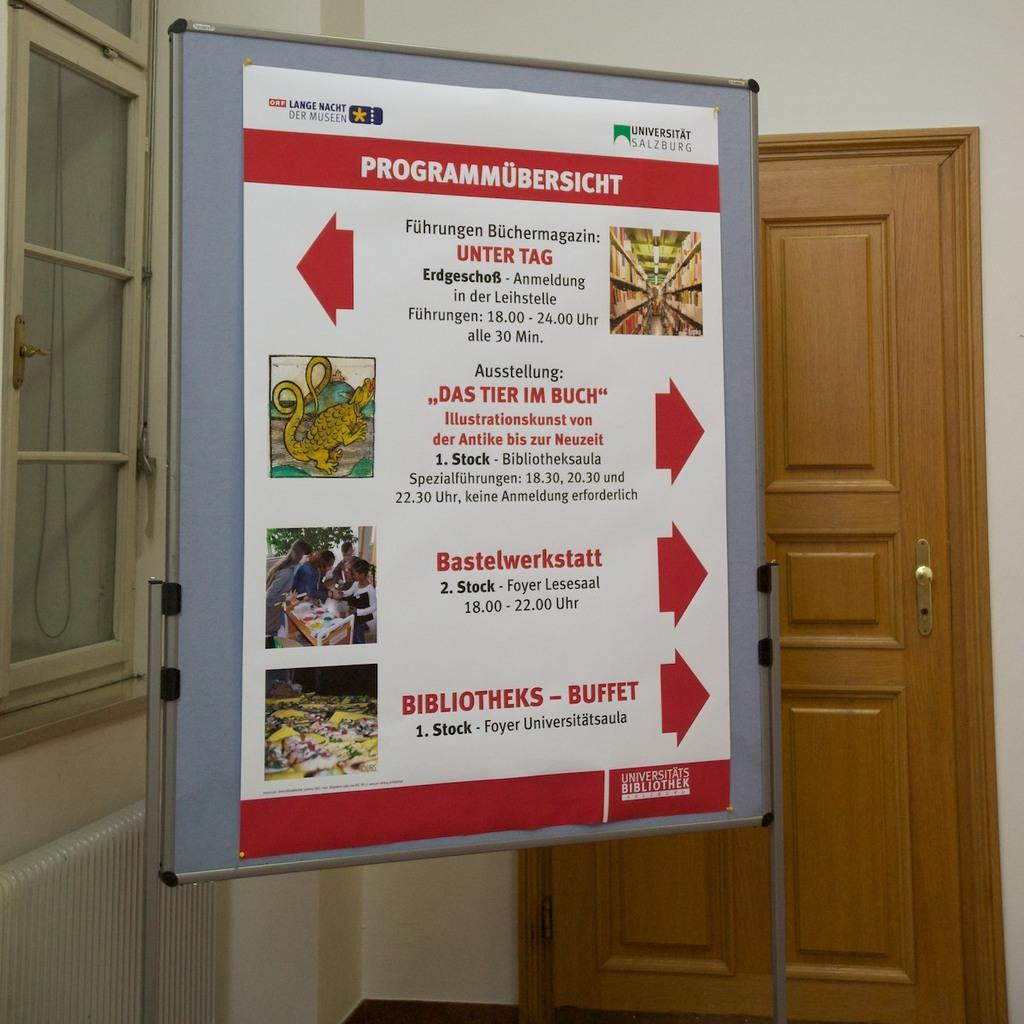<image>
Describe the image concisely. A white and red directory sign has program at the top. 